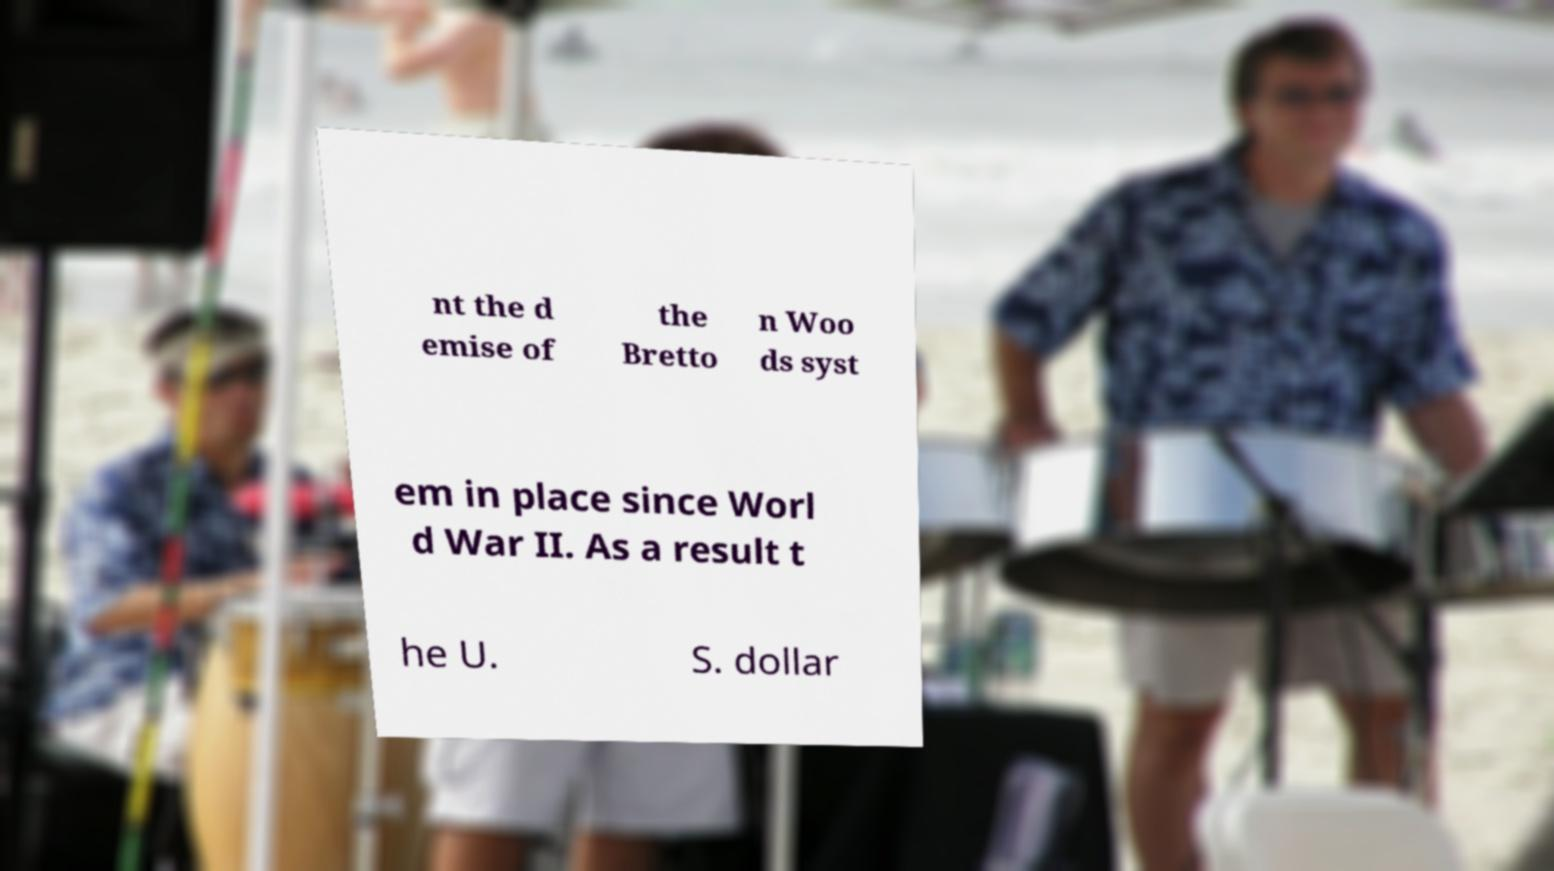Please identify and transcribe the text found in this image. nt the d emise of the Bretto n Woo ds syst em in place since Worl d War II. As a result t he U. S. dollar 